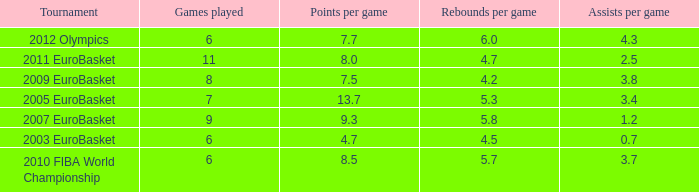How many games played have 4.7 as points per game? 6.0. 